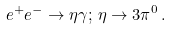<formula> <loc_0><loc_0><loc_500><loc_500>e ^ { + } e ^ { - } \to \eta \gamma ; \, \eta \to 3 \pi ^ { 0 } \, .</formula> 